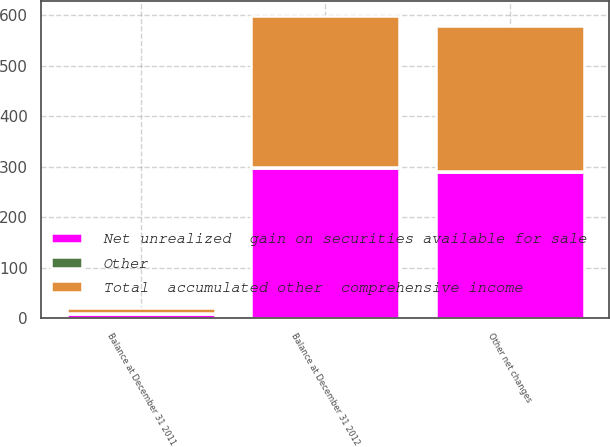Convert chart. <chart><loc_0><loc_0><loc_500><loc_500><stacked_bar_chart><ecel><fcel>Balance at December 31 2011<fcel>Other net changes<fcel>Balance at December 31 2012<nl><fcel>Total  accumulated other  comprehensive income<fcel>10<fcel>289<fcel>299<nl><fcel>Other<fcel>2<fcel>1<fcel>1<nl><fcel>Net unrealized  gain on securities available for sale<fcel>8<fcel>290<fcel>298<nl></chart> 